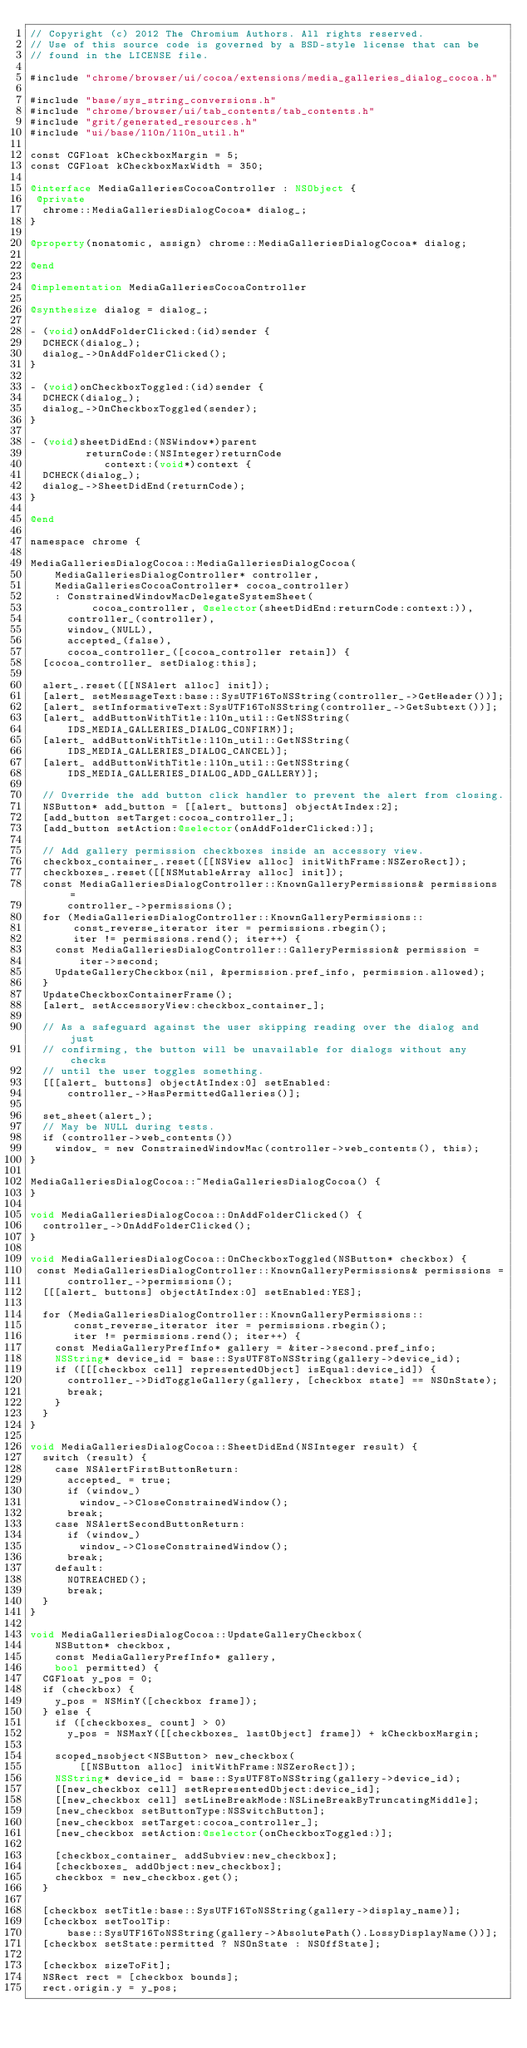Convert code to text. <code><loc_0><loc_0><loc_500><loc_500><_ObjectiveC_>// Copyright (c) 2012 The Chromium Authors. All rights reserved.
// Use of this source code is governed by a BSD-style license that can be
// found in the LICENSE file.

#include "chrome/browser/ui/cocoa/extensions/media_galleries_dialog_cocoa.h"

#include "base/sys_string_conversions.h"
#include "chrome/browser/ui/tab_contents/tab_contents.h"
#include "grit/generated_resources.h"
#include "ui/base/l10n/l10n_util.h"

const CGFloat kCheckboxMargin = 5;
const CGFloat kCheckboxMaxWidth = 350;

@interface MediaGalleriesCocoaController : NSObject {
 @private
  chrome::MediaGalleriesDialogCocoa* dialog_;
}

@property(nonatomic, assign) chrome::MediaGalleriesDialogCocoa* dialog;

@end

@implementation MediaGalleriesCocoaController

@synthesize dialog = dialog_;

- (void)onAddFolderClicked:(id)sender {
  DCHECK(dialog_);
  dialog_->OnAddFolderClicked();
}

- (void)onCheckboxToggled:(id)sender {
  DCHECK(dialog_);
  dialog_->OnCheckboxToggled(sender);
}

- (void)sheetDidEnd:(NSWindow*)parent
         returnCode:(NSInteger)returnCode
            context:(void*)context {
  DCHECK(dialog_);
  dialog_->SheetDidEnd(returnCode);
}

@end

namespace chrome {

MediaGalleriesDialogCocoa::MediaGalleriesDialogCocoa(
    MediaGalleriesDialogController* controller,
    MediaGalleriesCocoaController* cocoa_controller)
    : ConstrainedWindowMacDelegateSystemSheet(
          cocoa_controller, @selector(sheetDidEnd:returnCode:context:)),
      controller_(controller),
      window_(NULL),
      accepted_(false),
      cocoa_controller_([cocoa_controller retain]) {
  [cocoa_controller_ setDialog:this];

  alert_.reset([[NSAlert alloc] init]);
  [alert_ setMessageText:base::SysUTF16ToNSString(controller_->GetHeader())];
  [alert_ setInformativeText:SysUTF16ToNSString(controller_->GetSubtext())];
  [alert_ addButtonWithTitle:l10n_util::GetNSString(
      IDS_MEDIA_GALLERIES_DIALOG_CONFIRM)];
  [alert_ addButtonWithTitle:l10n_util::GetNSString(
      IDS_MEDIA_GALLERIES_DIALOG_CANCEL)];
  [alert_ addButtonWithTitle:l10n_util::GetNSString(
      IDS_MEDIA_GALLERIES_DIALOG_ADD_GALLERY)];

  // Override the add button click handler to prevent the alert from closing.
  NSButton* add_button = [[alert_ buttons] objectAtIndex:2];
  [add_button setTarget:cocoa_controller_];
  [add_button setAction:@selector(onAddFolderClicked:)];

  // Add gallery permission checkboxes inside an accessory view.
  checkbox_container_.reset([[NSView alloc] initWithFrame:NSZeroRect]);
  checkboxes_.reset([[NSMutableArray alloc] init]);
  const MediaGalleriesDialogController::KnownGalleryPermissions& permissions =
      controller_->permissions();
  for (MediaGalleriesDialogController::KnownGalleryPermissions::
       const_reverse_iterator iter = permissions.rbegin();
       iter != permissions.rend(); iter++) {
    const MediaGalleriesDialogController::GalleryPermission& permission =
        iter->second;
    UpdateGalleryCheckbox(nil, &permission.pref_info, permission.allowed);
  }
  UpdateCheckboxContainerFrame();
  [alert_ setAccessoryView:checkbox_container_];

  // As a safeguard against the user skipping reading over the dialog and just
  // confirming, the button will be unavailable for dialogs without any checks
  // until the user toggles something.
  [[[alert_ buttons] objectAtIndex:0] setEnabled:
      controller_->HasPermittedGalleries()];

  set_sheet(alert_);
  // May be NULL during tests.
  if (controller->web_contents())
    window_ = new ConstrainedWindowMac(controller->web_contents(), this);
}

MediaGalleriesDialogCocoa::~MediaGalleriesDialogCocoa() {
}

void MediaGalleriesDialogCocoa::OnAddFolderClicked() {
  controller_->OnAddFolderClicked();
}

void MediaGalleriesDialogCocoa::OnCheckboxToggled(NSButton* checkbox) {
 const MediaGalleriesDialogController::KnownGalleryPermissions& permissions =
      controller_->permissions();
  [[[alert_ buttons] objectAtIndex:0] setEnabled:YES];

  for (MediaGalleriesDialogController::KnownGalleryPermissions::
       const_reverse_iterator iter = permissions.rbegin();
       iter != permissions.rend(); iter++) {
    const MediaGalleryPrefInfo* gallery = &iter->second.pref_info;
    NSString* device_id = base::SysUTF8ToNSString(gallery->device_id);
    if ([[[checkbox cell] representedObject] isEqual:device_id]) {
      controller_->DidToggleGallery(gallery, [checkbox state] == NSOnState);
      break;
    }
  }
}

void MediaGalleriesDialogCocoa::SheetDidEnd(NSInteger result) {
  switch (result) {
    case NSAlertFirstButtonReturn:
      accepted_ = true;
      if (window_)
        window_->CloseConstrainedWindow();
      break;
    case NSAlertSecondButtonReturn:
      if (window_)
        window_->CloseConstrainedWindow();
      break;
    default:
      NOTREACHED();
      break;
  }
}

void MediaGalleriesDialogCocoa::UpdateGalleryCheckbox(
    NSButton* checkbox,
    const MediaGalleryPrefInfo* gallery,
    bool permitted) {
  CGFloat y_pos = 0;
  if (checkbox) {
    y_pos = NSMinY([checkbox frame]);
  } else {
    if ([checkboxes_ count] > 0)
      y_pos = NSMaxY([[checkboxes_ lastObject] frame]) + kCheckboxMargin;

    scoped_nsobject<NSButton> new_checkbox(
        [[NSButton alloc] initWithFrame:NSZeroRect]);
    NSString* device_id = base::SysUTF8ToNSString(gallery->device_id);
    [[new_checkbox cell] setRepresentedObject:device_id];
    [[new_checkbox cell] setLineBreakMode:NSLineBreakByTruncatingMiddle];
    [new_checkbox setButtonType:NSSwitchButton];
    [new_checkbox setTarget:cocoa_controller_];
    [new_checkbox setAction:@selector(onCheckboxToggled:)];

    [checkbox_container_ addSubview:new_checkbox];
    [checkboxes_ addObject:new_checkbox];
    checkbox = new_checkbox.get();
  }

  [checkbox setTitle:base::SysUTF16ToNSString(gallery->display_name)];
  [checkbox setToolTip:
      base::SysUTF16ToNSString(gallery->AbsolutePath().LossyDisplayName())];
  [checkbox setState:permitted ? NSOnState : NSOffState];

  [checkbox sizeToFit];
  NSRect rect = [checkbox bounds];
  rect.origin.y = y_pos;</code> 